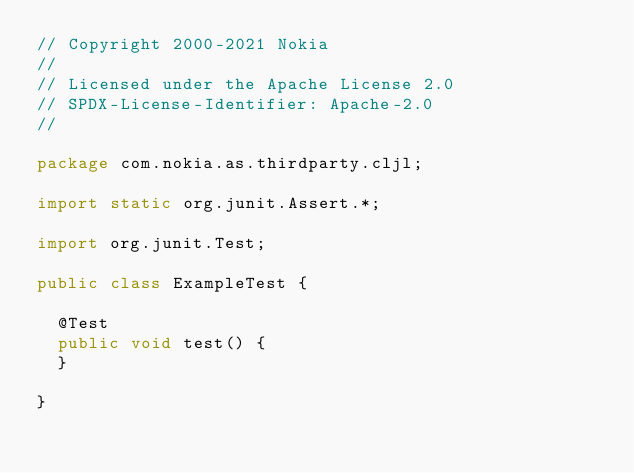Convert code to text. <code><loc_0><loc_0><loc_500><loc_500><_Java_>// Copyright 2000-2021 Nokia
//
// Licensed under the Apache License 2.0
// SPDX-License-Identifier: Apache-2.0
//

package com.nokia.as.thirdparty.cljl;

import static org.junit.Assert.*;

import org.junit.Test;

public class ExampleTest {

	@Test
	public void test() {
	}

}
</code> 